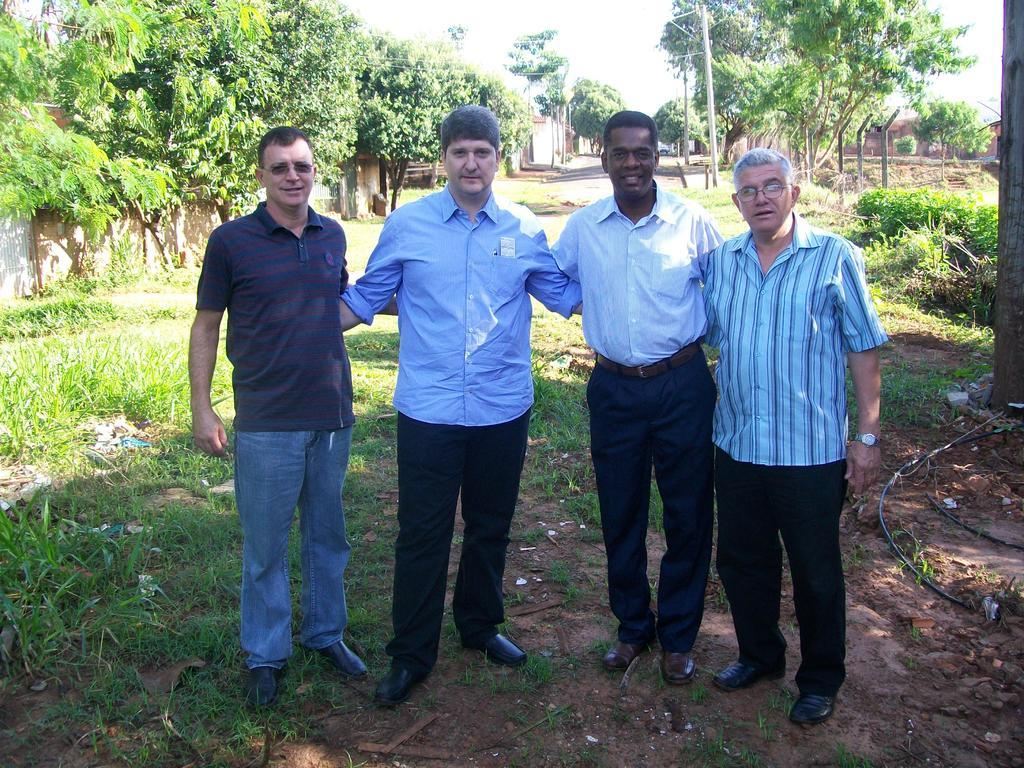How many people are present in the image? There are four people in the image. What is the surface that the people are standing on? The people are standing on the surface of grass. What expressions do the people have on their faces? The people have smiles on their faces. What can be seen in the background of the image? There are trees, buildings, and the sky visible in the background of the image. What is the name of the governor of the country depicted in the image? There is no indication of a specific country or governor in the image. 